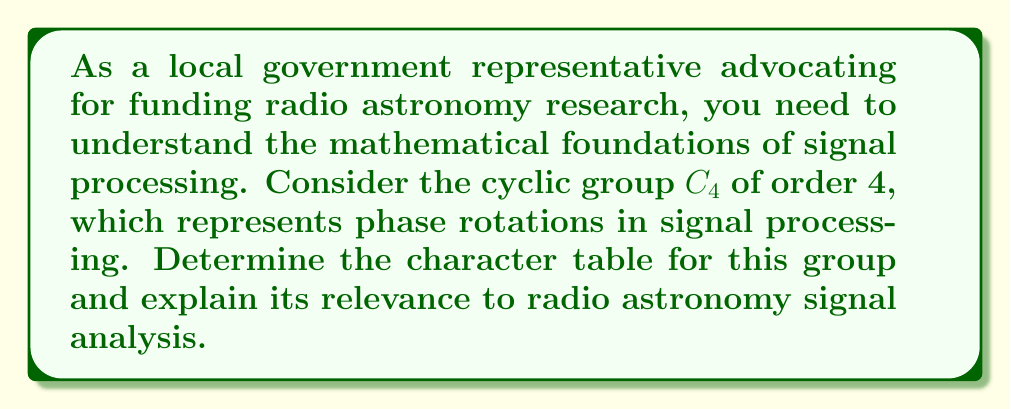Solve this math problem. Let's construct the character table for the cyclic group $C_4$ step by step:

1) First, recall that $C_4 = \{e, a, a^2, a^3\}$, where $e$ is the identity element and $a$ is a generator of the group.

2) $C_4$ has 4 conjugacy classes, each containing one element: $\{e\}, \{a\}, \{a^2\}, \{a^3\}$.

3) The number of irreducible representations equals the number of conjugacy classes, so we expect 4 irreducible representations.

4) For a cyclic group, all irreducible representations are one-dimensional.

5) Let $\chi_j$ denote the $j$-th irreducible character. We can express these as:

   $\chi_j(a^k) = (\omega^j)^k = e^{2\pi ijk/4}$, where $\omega = e^{2\pi i/4} = i$

6) Calculating the values:
   
   $\chi_0(e) = 1, \chi_0(a) = 1, \chi_0(a^2) = 1, \chi_0(a^3) = 1$
   $\chi_1(e) = 1, \chi_1(a) = i, \chi_1(a^2) = -1, \chi_1(a^3) = -i$
   $\chi_2(e) = 1, \chi_2(a) = -1, \chi_2(a^2) = 1, \chi_2(a^3) = -1$
   $\chi_3(e) = 1, \chi_3(a) = -i, \chi_3(a^2) = -1, \chi_3(a^3) = i$

7) The character table is thus:

   $$
   \begin{array}{c|cccc}
    C_4 & e & a & a^2 & a^3 \\
   \hline
   \chi_0 & 1 & 1 & 1 & 1 \\
   \chi_1 & 1 & i & -1 & -i \\
   \chi_2 & 1 & -1 & 1 & -1 \\
   \chi_3 & 1 & -i & -1 & i
   \end{array}
   $$

Relevance to radio astronomy:
In radio astronomy signal processing, phase rotations are crucial for analyzing and manipulating signals. The characters of $C_4$ represent different phase rotations (0°, 90°, 180°, 270°) that can be applied to signals. Understanding these rotations and their properties helps in various signal processing tasks, such as phase correction, signal combination, and interference mitigation, which are essential for improving the quality and accuracy of radio astronomical observations.
Answer: Character table of $C_4$:
$$
\begin{array}{c|cccc}
C_4 & e & a & a^2 & a^3 \\
\hline
\chi_0 & 1 & 1 & 1 & 1 \\
\chi_1 & 1 & i & -1 & -i \\
\chi_2 & 1 & -1 & 1 & -1 \\
\chi_3 & 1 & -i & -1 & i
\end{array}
$$ 